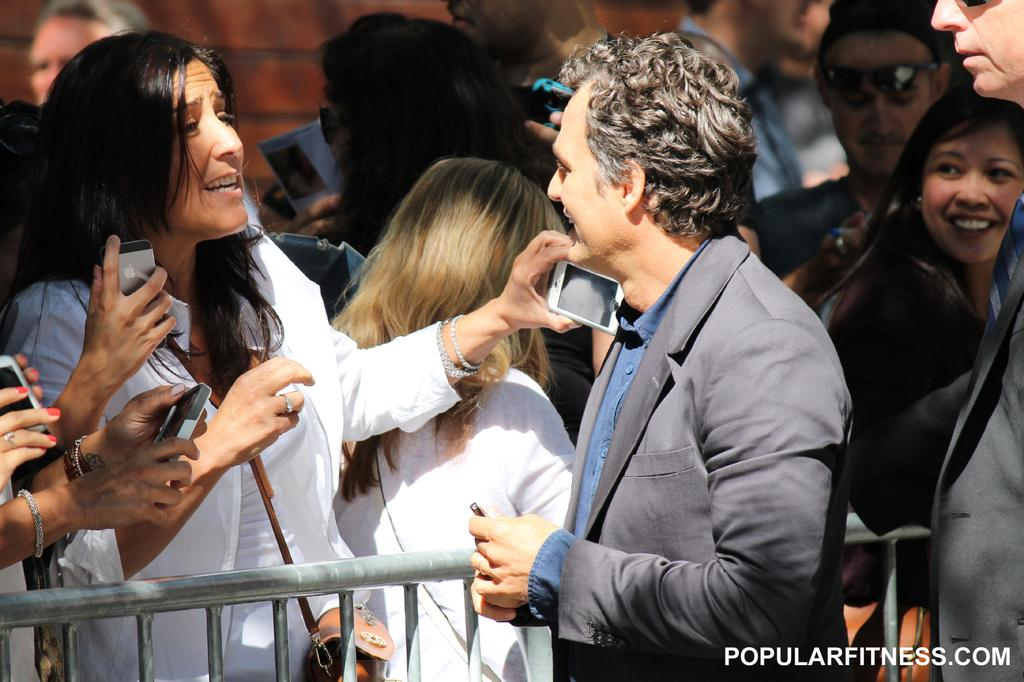What are the people in the image doing? The people in the image are standing and holding mobiles. What separates two of the people in the image? There is a fence between two people in the image. Can you describe the background of the image? There are people and a wall visible in the background of the image. What type of caption is written on the wall in the image? There is no caption written on the wall in the image. Can you tell me how many aunts are present in the image? There is no mention of an aunt in the image, and therefore no such person can be identified. 